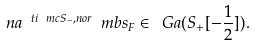Convert formula to latex. <formula><loc_0><loc_0><loc_500><loc_500>\ n a ^ { \ t i { \ m c { S } } _ { - } , n o r } \ m b { s } _ { F } \in \ G a ( S _ { + } [ - \frac { 1 } { 2 } ] ) .</formula> 